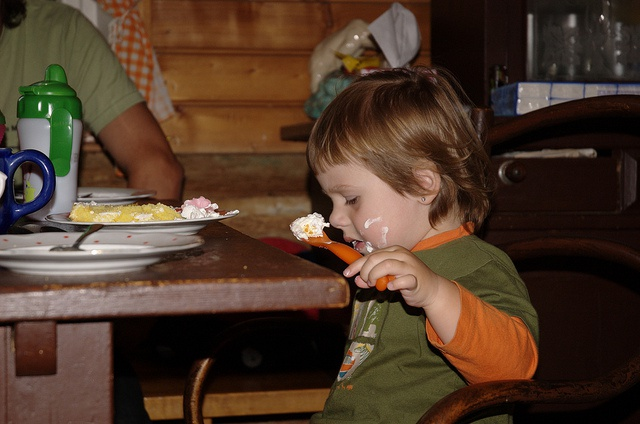Describe the objects in this image and their specific colors. I can see people in black, olive, maroon, and brown tones, dining table in black, brown, maroon, and gray tones, chair in black, maroon, and darkgreen tones, people in black, gray, and maroon tones, and bottle in black, darkgreen, darkgray, and gray tones in this image. 